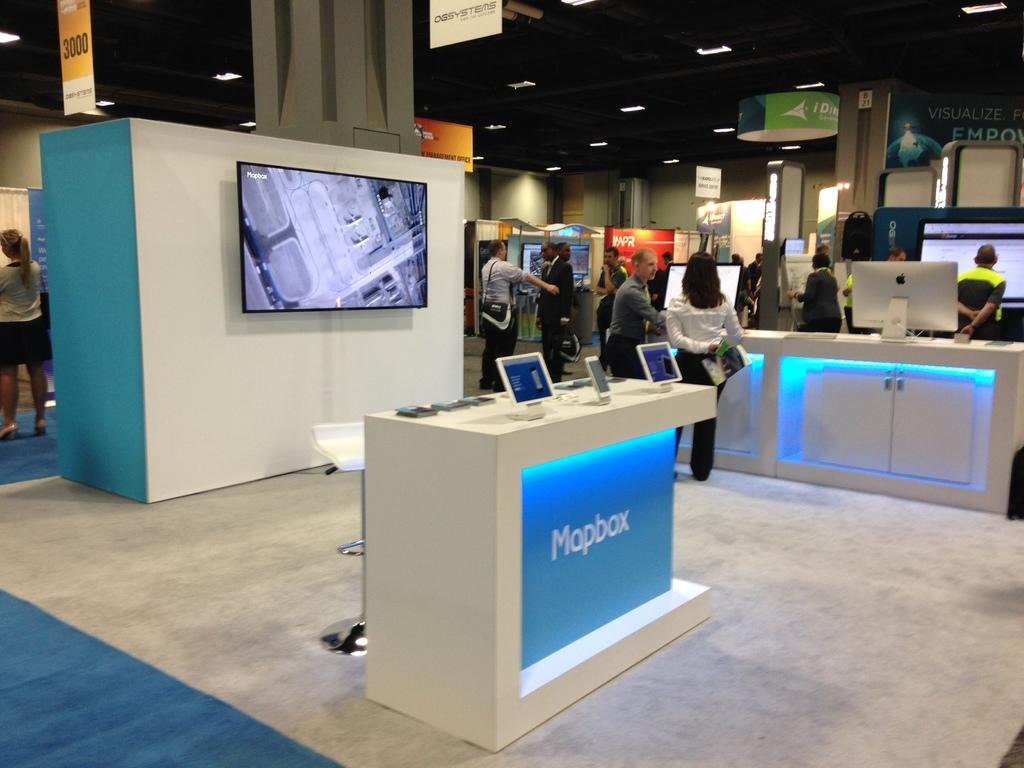What are the people in the image doing? The people in the image are on the floor. What electronic devices can be seen in the image? There are monitors and screens in the image. What can be found in the image besides people and electronic devices? There are objects in the image. What is visible in the background of the image? There is a wall, lights, and a roof in the background of the image. What type of dust can be seen on the band's stocking in the image? There is no band or stocking present in the image, so it is not possible to determine the type of dust on them. 